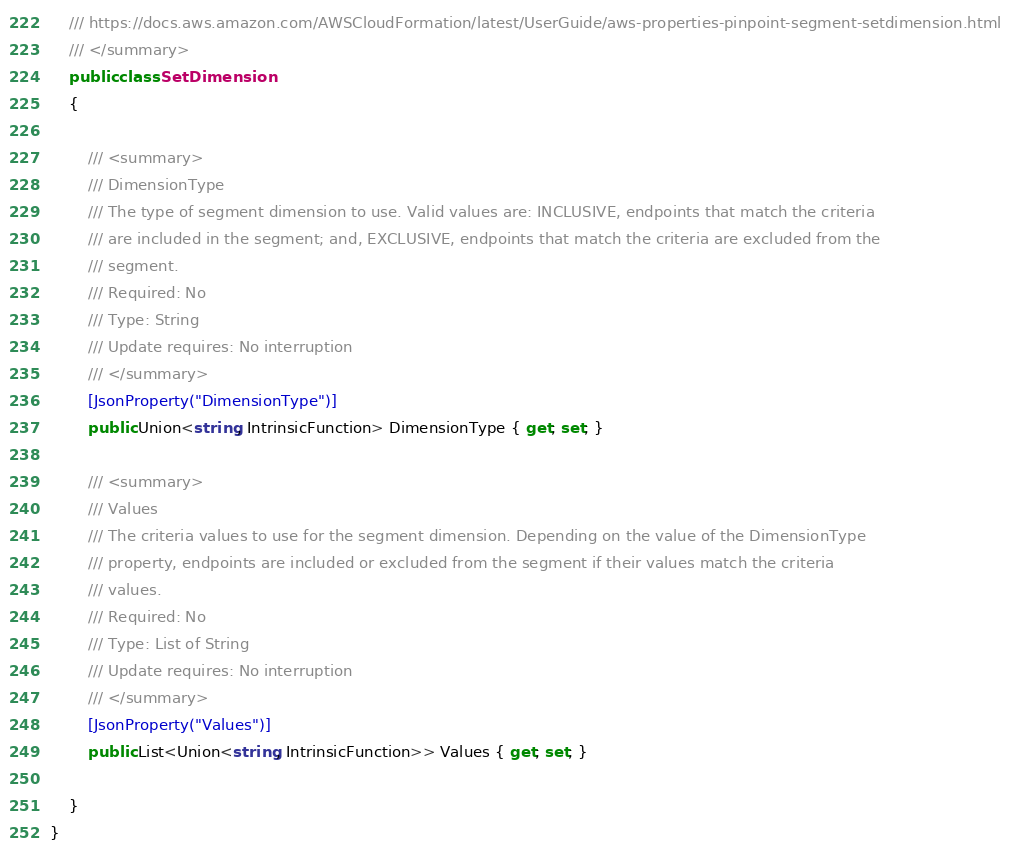Convert code to text. <code><loc_0><loc_0><loc_500><loc_500><_C#_>    /// https://docs.aws.amazon.com/AWSCloudFormation/latest/UserGuide/aws-properties-pinpoint-segment-setdimension.html
    /// </summary>
    public class SetDimension
    {

        /// <summary>
        /// DimensionType
        /// The type of segment dimension to use. Valid values are: INCLUSIVE, endpoints that match the criteria
        /// are included in the segment; and, EXCLUSIVE, endpoints that match the criteria are excluded from the
        /// segment.
        /// Required: No
        /// Type: String
        /// Update requires: No interruption
        /// </summary>
        [JsonProperty("DimensionType")]
        public Union<string, IntrinsicFunction> DimensionType { get; set; }

        /// <summary>
        /// Values
        /// The criteria values to use for the segment dimension. Depending on the value of the DimensionType
        /// property, endpoints are included or excluded from the segment if their values match the criteria
        /// values.
        /// Required: No
        /// Type: List of String
        /// Update requires: No interruption
        /// </summary>
        [JsonProperty("Values")]
        public List<Union<string, IntrinsicFunction>> Values { get; set; }

    }
}
</code> 